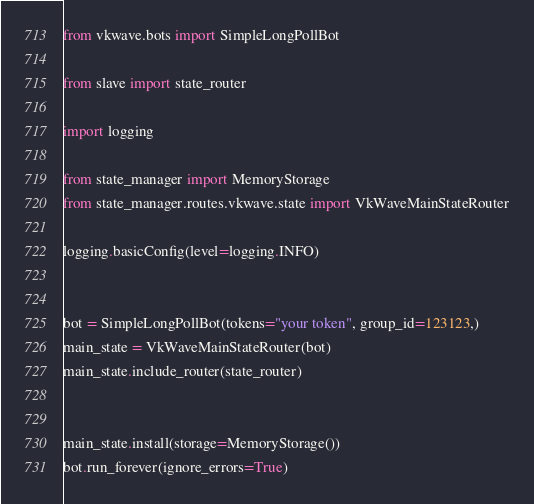Convert code to text. <code><loc_0><loc_0><loc_500><loc_500><_Python_>from vkwave.bots import SimpleLongPollBot

from slave import state_router

import logging

from state_manager import MemoryStorage
from state_manager.routes.vkwave.state import VkWaveMainStateRouter

logging.basicConfig(level=logging.INFO)


bot = SimpleLongPollBot(tokens="your token", group_id=123123,)
main_state = VkWaveMainStateRouter(bot)
main_state.include_router(state_router)


main_state.install(storage=MemoryStorage())
bot.run_forever(ignore_errors=True)
</code> 